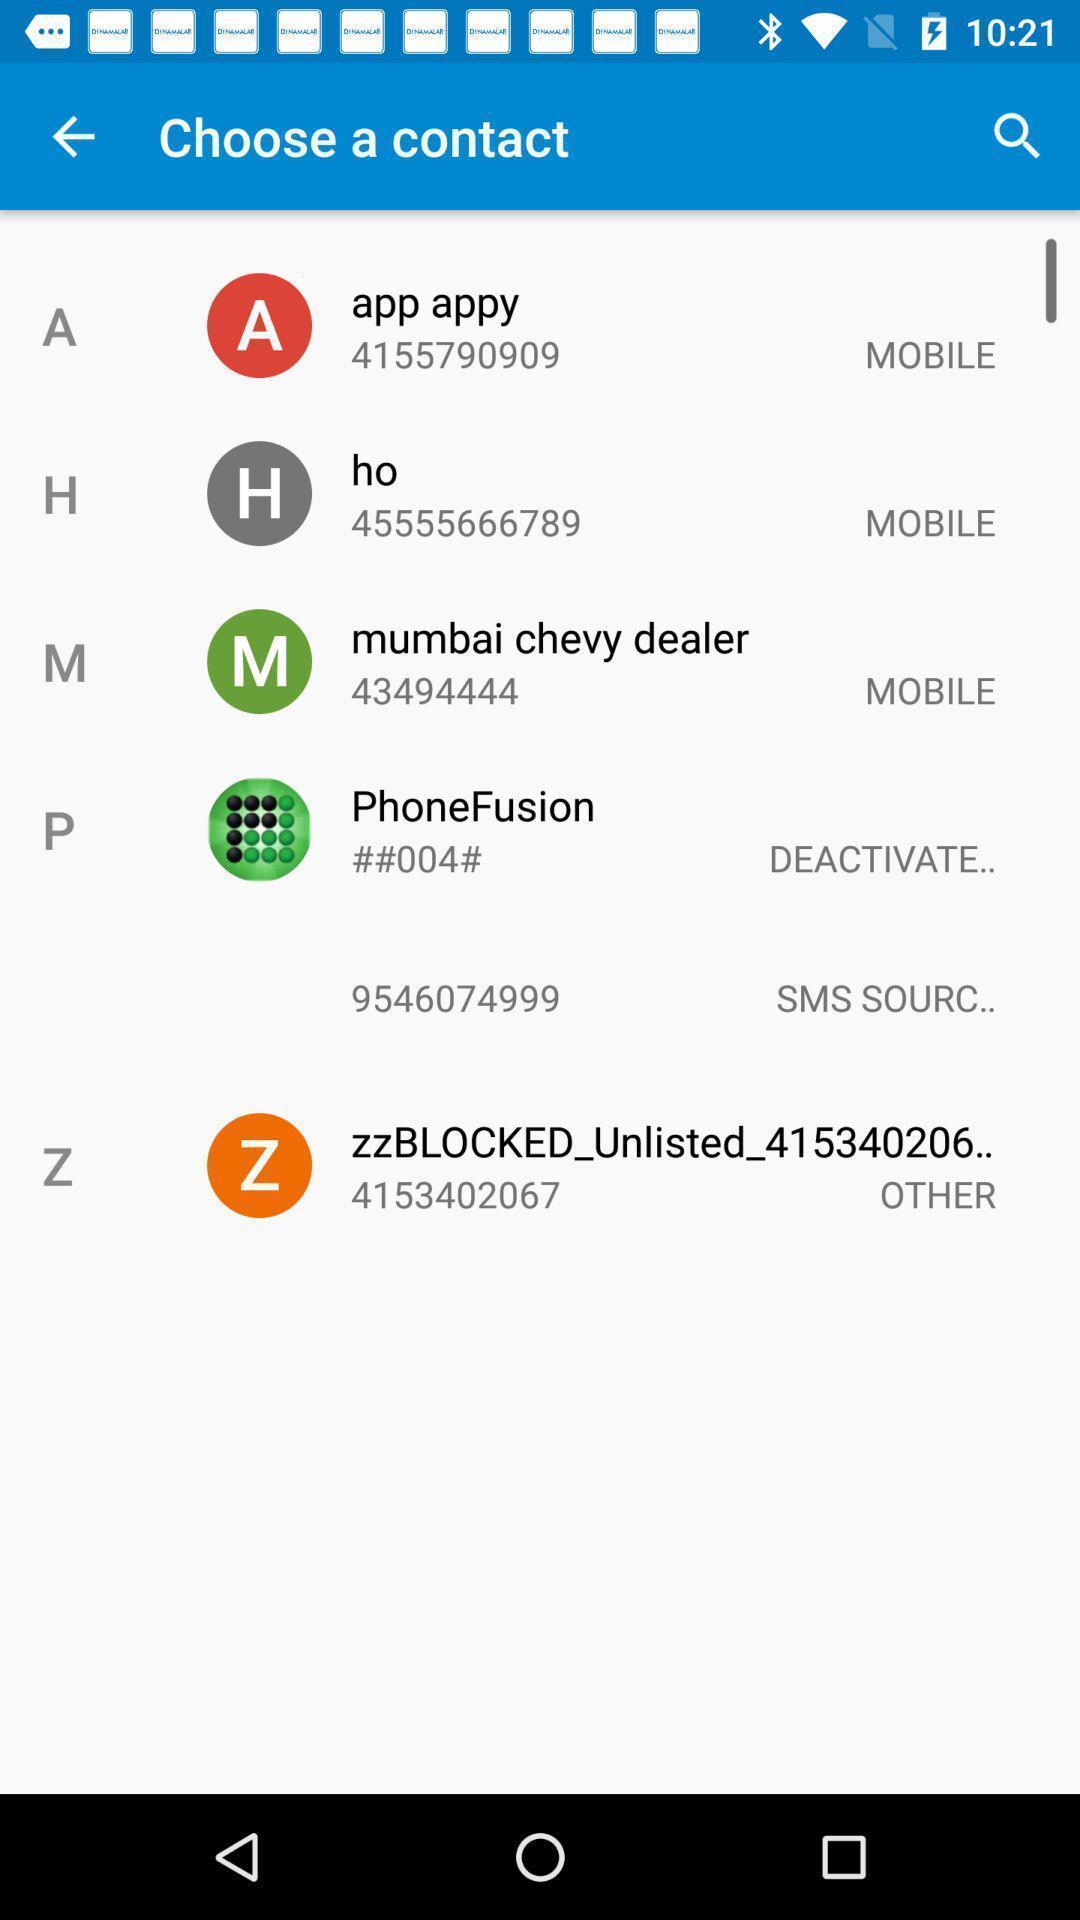Describe the content in this image. Page displays to choose a contact. 